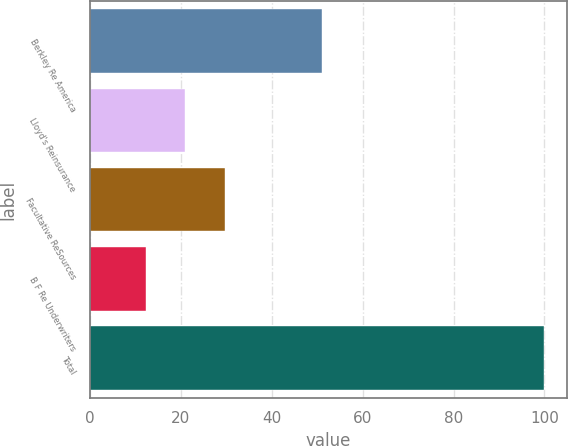Convert chart to OTSL. <chart><loc_0><loc_0><loc_500><loc_500><bar_chart><fcel>Berkley Re America<fcel>Lloyd's Reinsurance<fcel>Facultative ReSources<fcel>B F Re Underwriters<fcel>Total<nl><fcel>51<fcel>20.98<fcel>29.76<fcel>12.2<fcel>100<nl></chart> 